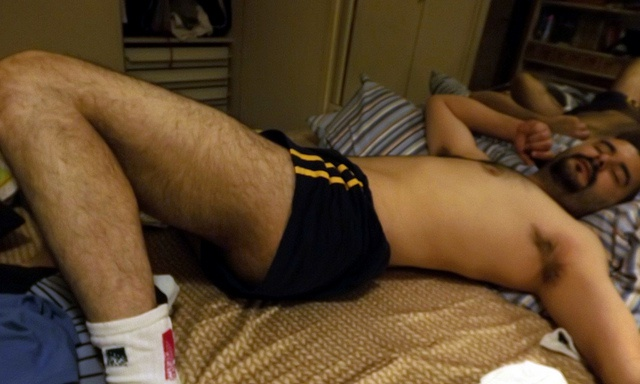Describe the objects in this image and their specific colors. I can see people in black, brown, gray, and maroon tones, bed in black and olive tones, and people in black, maroon, and gray tones in this image. 